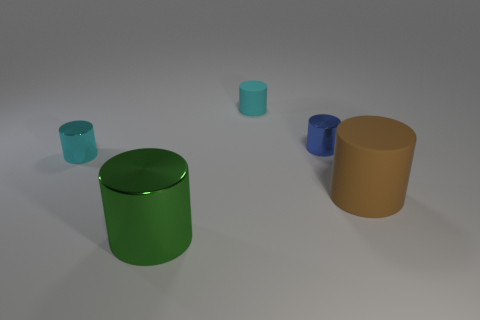Subtract all small matte cylinders. How many cylinders are left? 4 Add 3 rubber cylinders. How many objects exist? 8 Subtract all brown cylinders. How many cylinders are left? 4 Subtract 4 cylinders. How many cylinders are left? 1 Subtract all blue cylinders. Subtract all blue blocks. How many cylinders are left? 4 Subtract all blue cubes. How many green cylinders are left? 1 Subtract all matte cylinders. Subtract all cyan matte things. How many objects are left? 2 Add 3 big brown matte cylinders. How many big brown matte cylinders are left? 4 Add 5 small cyan metal cylinders. How many small cyan metal cylinders exist? 6 Subtract 0 yellow balls. How many objects are left? 5 